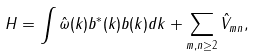Convert formula to latex. <formula><loc_0><loc_0><loc_500><loc_500>H = \int \hat { \omega } ( k ) b ^ { * } ( k ) b ( k ) d k + \sum _ { m , n \geq 2 } \hat { V } _ { m n } ,</formula> 